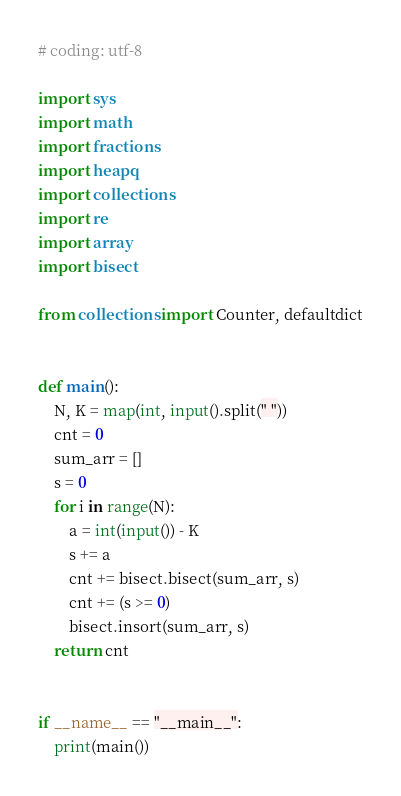Convert code to text. <code><loc_0><loc_0><loc_500><loc_500><_Python_># coding: utf-8

import sys
import math
import fractions
import heapq
import collections
import re
import array
import bisect

from collections import Counter, defaultdict


def main():
    N, K = map(int, input().split(" "))
    cnt = 0
    sum_arr = []
    s = 0
    for i in range(N):
        a = int(input()) - K
        s += a
        cnt += bisect.bisect(sum_arr, s)
        cnt += (s >= 0)
        bisect.insort(sum_arr, s)
    return cnt


if __name__ == "__main__":
    print(main())
</code> 